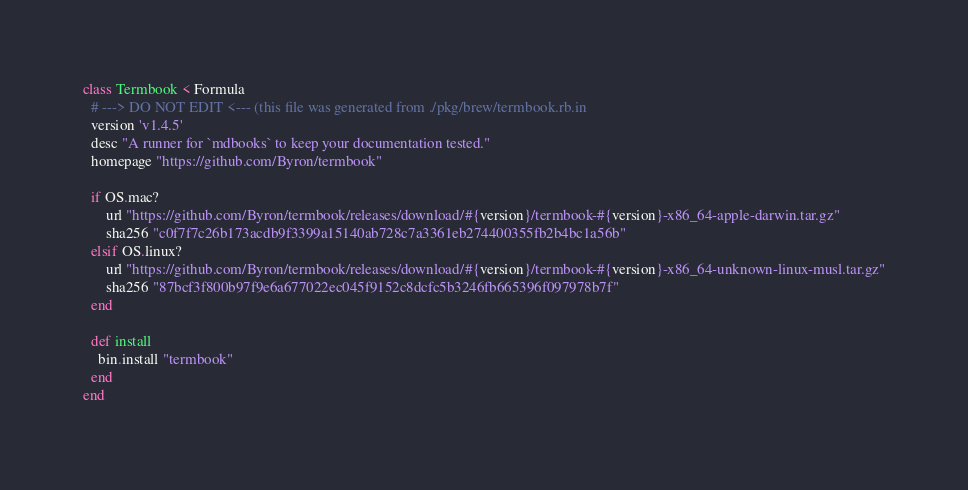Convert code to text. <code><loc_0><loc_0><loc_500><loc_500><_Ruby_>class Termbook < Formula
  # ---> DO NOT EDIT <--- (this file was generated from ./pkg/brew/termbook.rb.in
  version 'v1.4.5'
  desc "A runner for `mdbooks` to keep your documentation tested."
  homepage "https://github.com/Byron/termbook"

  if OS.mac?
      url "https://github.com/Byron/termbook/releases/download/#{version}/termbook-#{version}-x86_64-apple-darwin.tar.gz"
      sha256 "c0f7f7c26b173acdb9f3399a15140ab728c7a3361eb274400355fb2b4bc1a56b"
  elsif OS.linux?
      url "https://github.com/Byron/termbook/releases/download/#{version}/termbook-#{version}-x86_64-unknown-linux-musl.tar.gz"
      sha256 "87bcf3f800b97f9e6a677022ec045f9152c8dcfc5b3246fb665396f097978b7f"
  end

  def install
    bin.install "termbook"
  end
end
</code> 